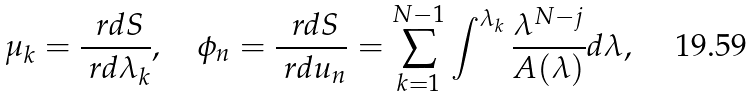Convert formula to latex. <formula><loc_0><loc_0><loc_500><loc_500>\mu _ { k } = \frac { \ r d S } { \ r d \lambda _ { k } } , \quad \phi _ { n } = \frac { \ r d S } { \ r d u _ { n } } = \sum _ { k = 1 } ^ { N - 1 } \int ^ { \lambda _ { k } } \frac { \lambda ^ { N - j } } { A ( \lambda ) } d \lambda ,</formula> 